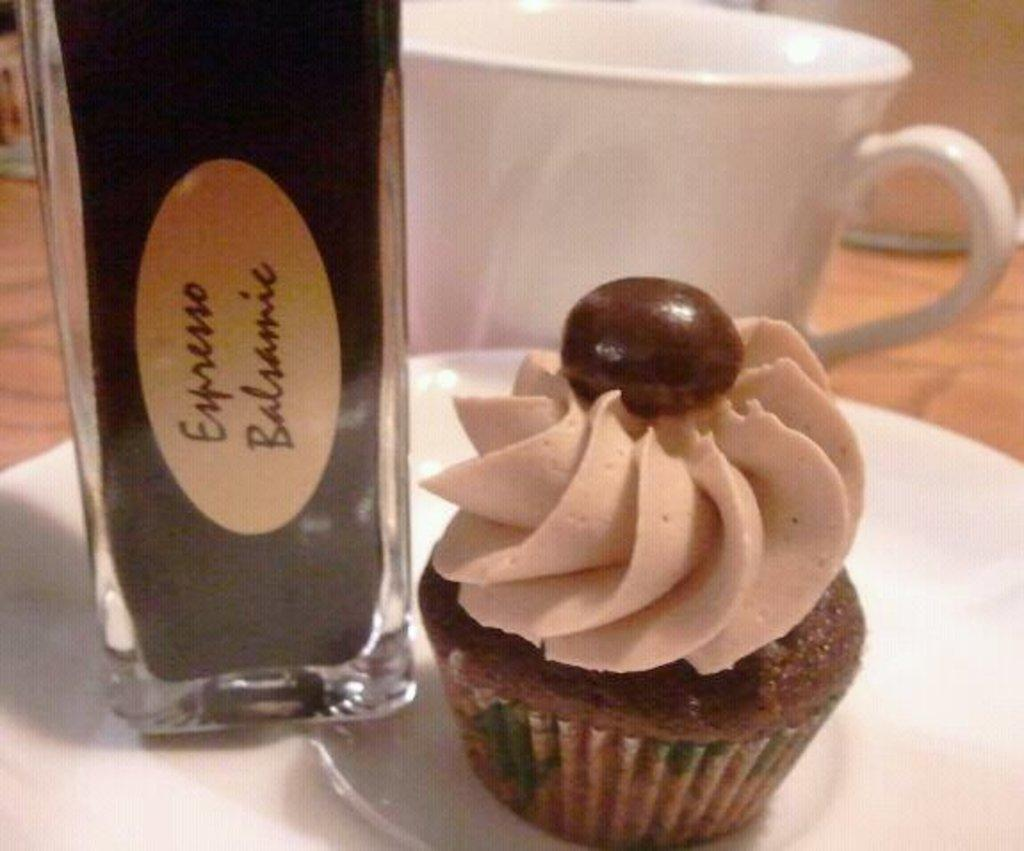Provide a one-sentence caption for the provided image. A container of espresso flavored balsamic is next to a cupcake. 